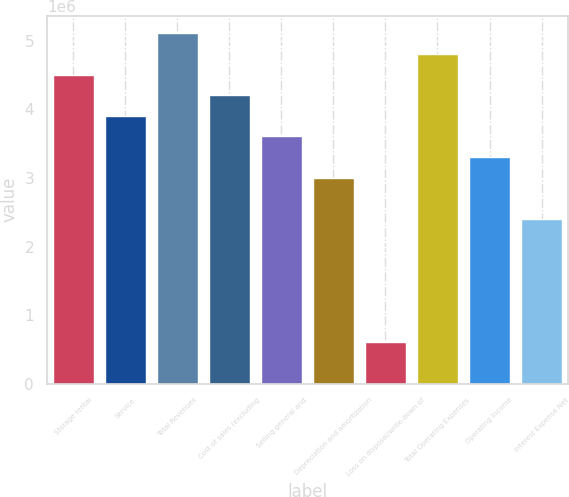Convert chart. <chart><loc_0><loc_0><loc_500><loc_500><bar_chart><fcel>Storage rental<fcel>Service<fcel>Total Revenues<fcel>Cost of sales (excluding<fcel>Selling general and<fcel>Depreciation and amortization<fcel>Loss on disposal/write-down of<fcel>Total Operating Expenses<fcel>Operating Income<fcel>Interest Expense Net<nl><fcel>4.50583e+06<fcel>3.90508e+06<fcel>5.10658e+06<fcel>4.20545e+06<fcel>3.6047e+06<fcel>3.00396e+06<fcel>600956<fcel>4.8062e+06<fcel>3.30433e+06<fcel>2.40321e+06<nl></chart> 